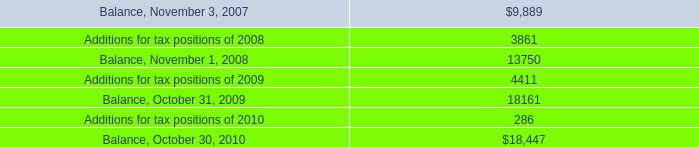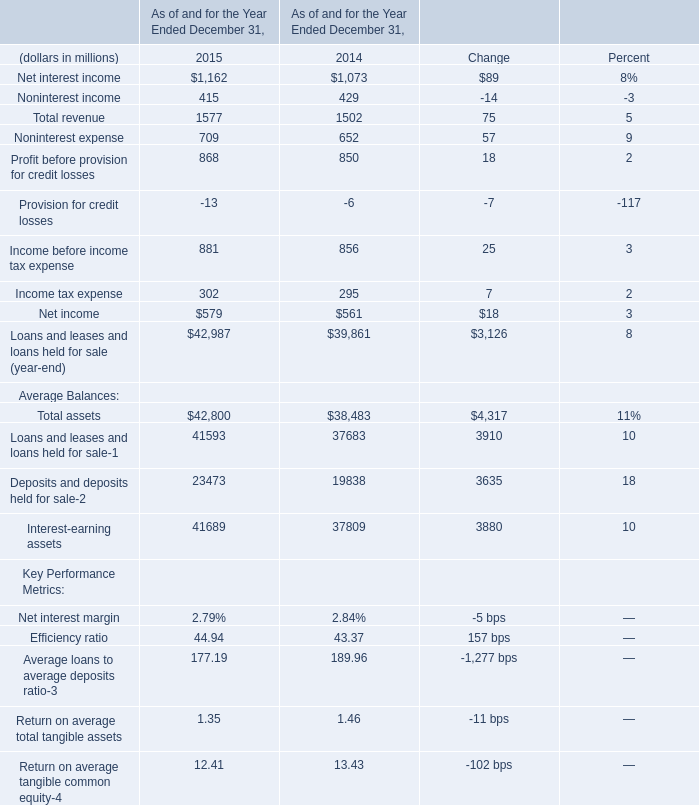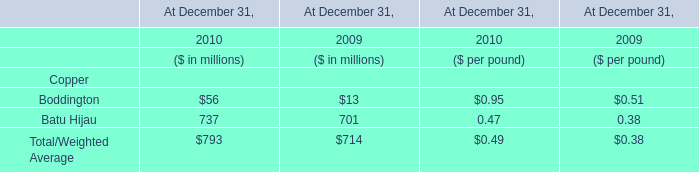what was the percentage increase of income for the fiscal years of 2008 to 2010? 
Computations: ((1.8 - 1.3) / 1.3)
Answer: 0.38462. 